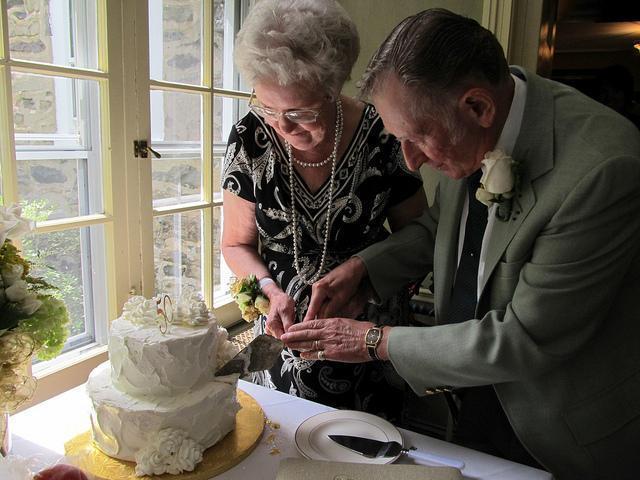Which occasion is this for?
From the following set of four choices, select the accurate answer to respond to the question.
Options: Birthday, anniversary, christmas, easter. Anniversary. 